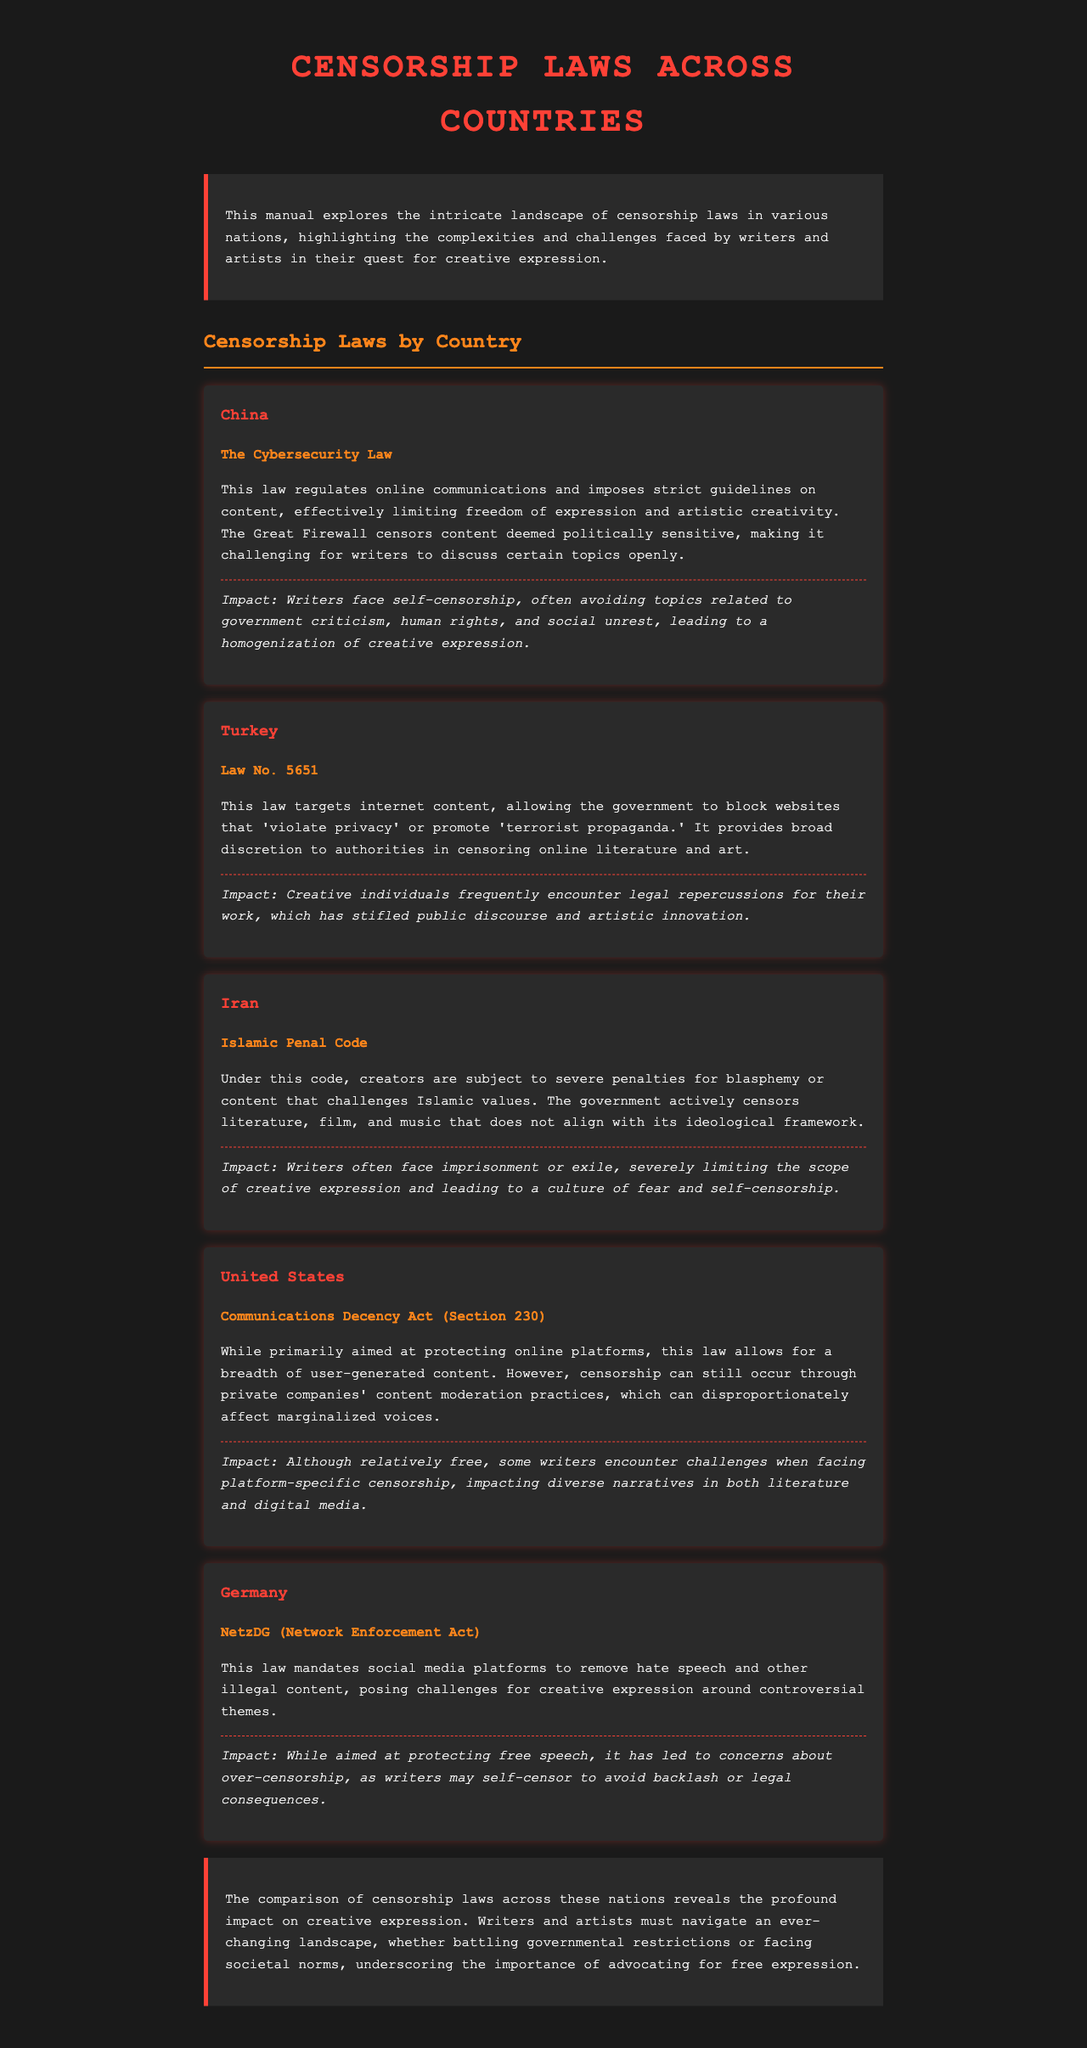What is the title of the manual? The title is presented prominently at the top of the document, summarizing its focus.
Answer: Censorship Laws Across Countries Which country has the Cybersecurity Law? The law is explicitly mentioned under the section detailing China's censorship laws.
Answer: China What type of penalties do Iranian writers face under the Islamic Penal Code? The text describes the consequences for creators whose works challenge Islamic values.
Answer: Imprisonment or exile What is the impact of Turkey's Law No. 5651 on public discourse? The document discusses how the law affects creative individuals in their artistic expression.
Answer: Stifled public discourse Which U.S. law is primarily aimed at protecting online platforms? The law referenced discusses its protective nature regarding user-generated content in the U.S.
Answer: Communications Decency Act (Section 230) According to the document, what challenges do writers in Germany face? The content outlines the implications of a specific law on controversial themes in creative works.
Answer: Over-censorship What color is used for headings in the document? The document describes the style choices made for header elements throughout.
Answer: Red What does the introduction highlight about censorship laws? It provides an overview of the themes explored within the manual.
Answer: Complexities and challenges faced by writers and artists How does the manual conclude about the role of writers and artists? The conclusion summarizes the ongoing struggles and emphasizes advocacy for free expression.
Answer: Importance of advocating for free expression 